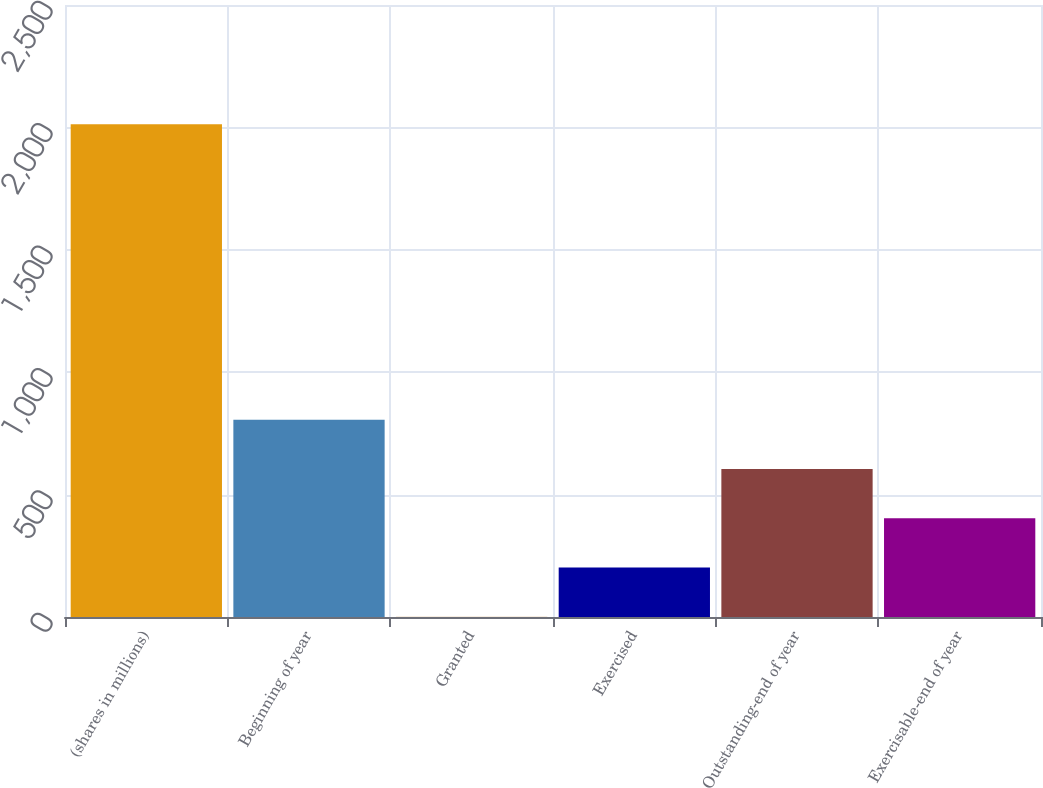<chart> <loc_0><loc_0><loc_500><loc_500><bar_chart><fcel>(shares in millions)<fcel>Beginning of year<fcel>Granted<fcel>Exercised<fcel>Outstanding-end of year<fcel>Exercisable-end of year<nl><fcel>2013<fcel>805.74<fcel>0.9<fcel>202.11<fcel>604.53<fcel>403.32<nl></chart> 